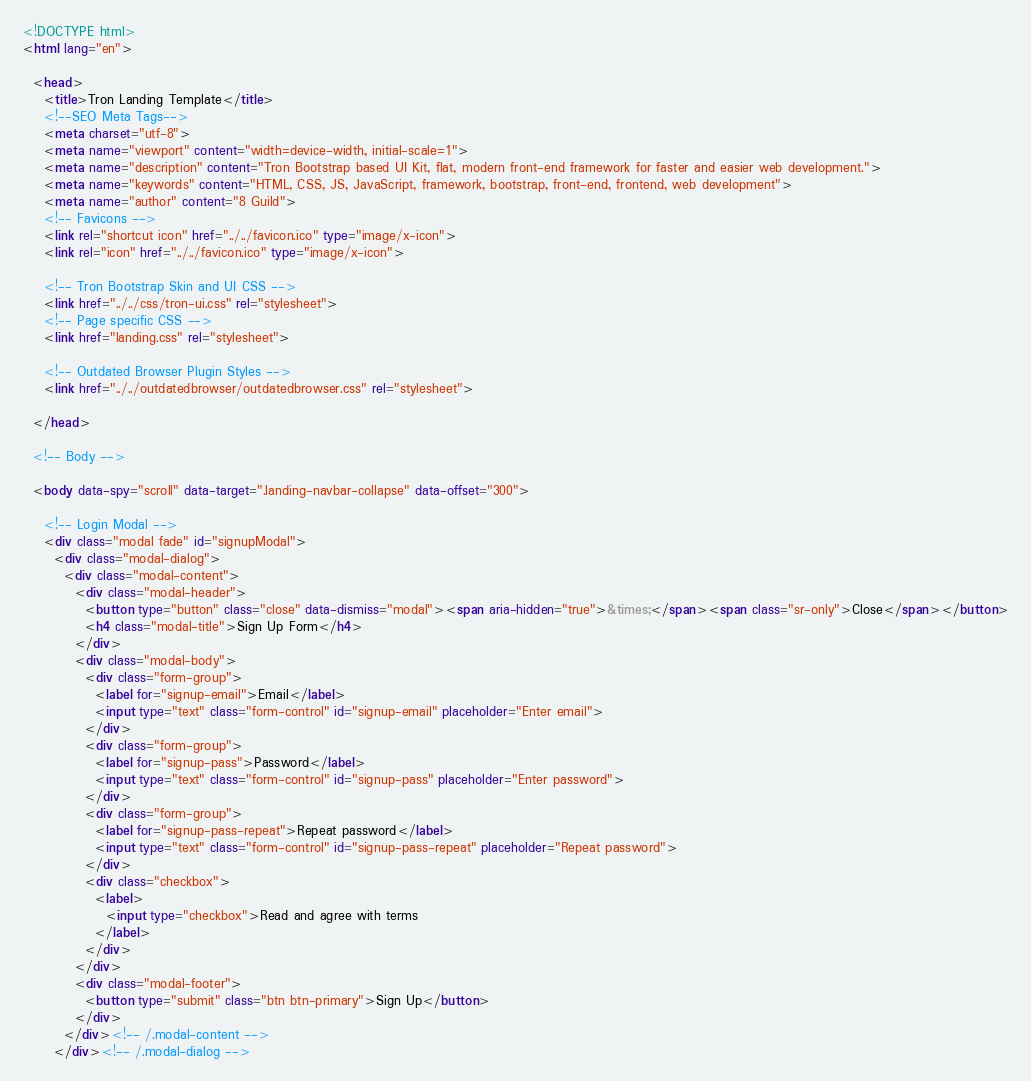Convert code to text. <code><loc_0><loc_0><loc_500><loc_500><_HTML_><!DOCTYPE html>
<html lang="en">

  <head>
    <title>Tron Landing Template</title>
    <!--SEO Meta Tags-->
    <meta charset="utf-8">
    <meta name="viewport" content="width=device-width, initial-scale=1">
    <meta name="description" content="Tron Bootstrap based UI Kit, flat, modern front-end framework for faster and easier web development.">
    <meta name="keywords" content="HTML, CSS, JS, JavaScript, framework, bootstrap, front-end, frontend, web development">
    <meta name="author" content="8 Guild">
    <!-- Favicons -->
    <link rel="shortcut icon" href="../../favicon.ico" type="image/x-icon">
    <link rel="icon" href="../../favicon.ico" type="image/x-icon">

    <!-- Tron Bootstrap Skin and UI CSS -->
    <link href="../../css/tron-ui.css" rel="stylesheet">
    <!-- Page specific CSS -->
    <link href="landing.css" rel="stylesheet">

    <!-- Outdated Browser Plugin Styles -->
    <link href="../../outdatedbrowser/outdatedbrowser.css" rel="stylesheet">

  </head>

  <!-- Body -->

  <body data-spy="scroll" data-target=".landing-navbar-collapse" data-offset="300">
    
    <!-- Login Modal -->
    <div class="modal fade" id="signupModal">
      <div class="modal-dialog">
        <div class="modal-content">
          <div class="modal-header">
            <button type="button" class="close" data-dismiss="modal"><span aria-hidden="true">&times;</span><span class="sr-only">Close</span></button>
            <h4 class="modal-title">Sign Up Form</h4>
          </div>
          <div class="modal-body">
            <div class="form-group">
              <label for="signup-email">Email</label>
              <input type="text" class="form-control" id="signup-email" placeholder="Enter email">
            </div>
            <div class="form-group">
              <label for="signup-pass">Password</label>
              <input type="text" class="form-control" id="signup-pass" placeholder="Enter password">
            </div>
            <div class="form-group">
              <label for="signup-pass-repeat">Repeat password</label>
              <input type="text" class="form-control" id="signup-pass-repeat" placeholder="Repeat password">
            </div>
            <div class="checkbox">
              <label>
                <input type="checkbox">Read and agree with terms
              </label>
            </div>
          </div>
          <div class="modal-footer">
            <button type="submit" class="btn btn-primary">Sign Up</button>
          </div>
        </div><!-- /.modal-content -->
      </div><!-- /.modal-dialog --></code> 